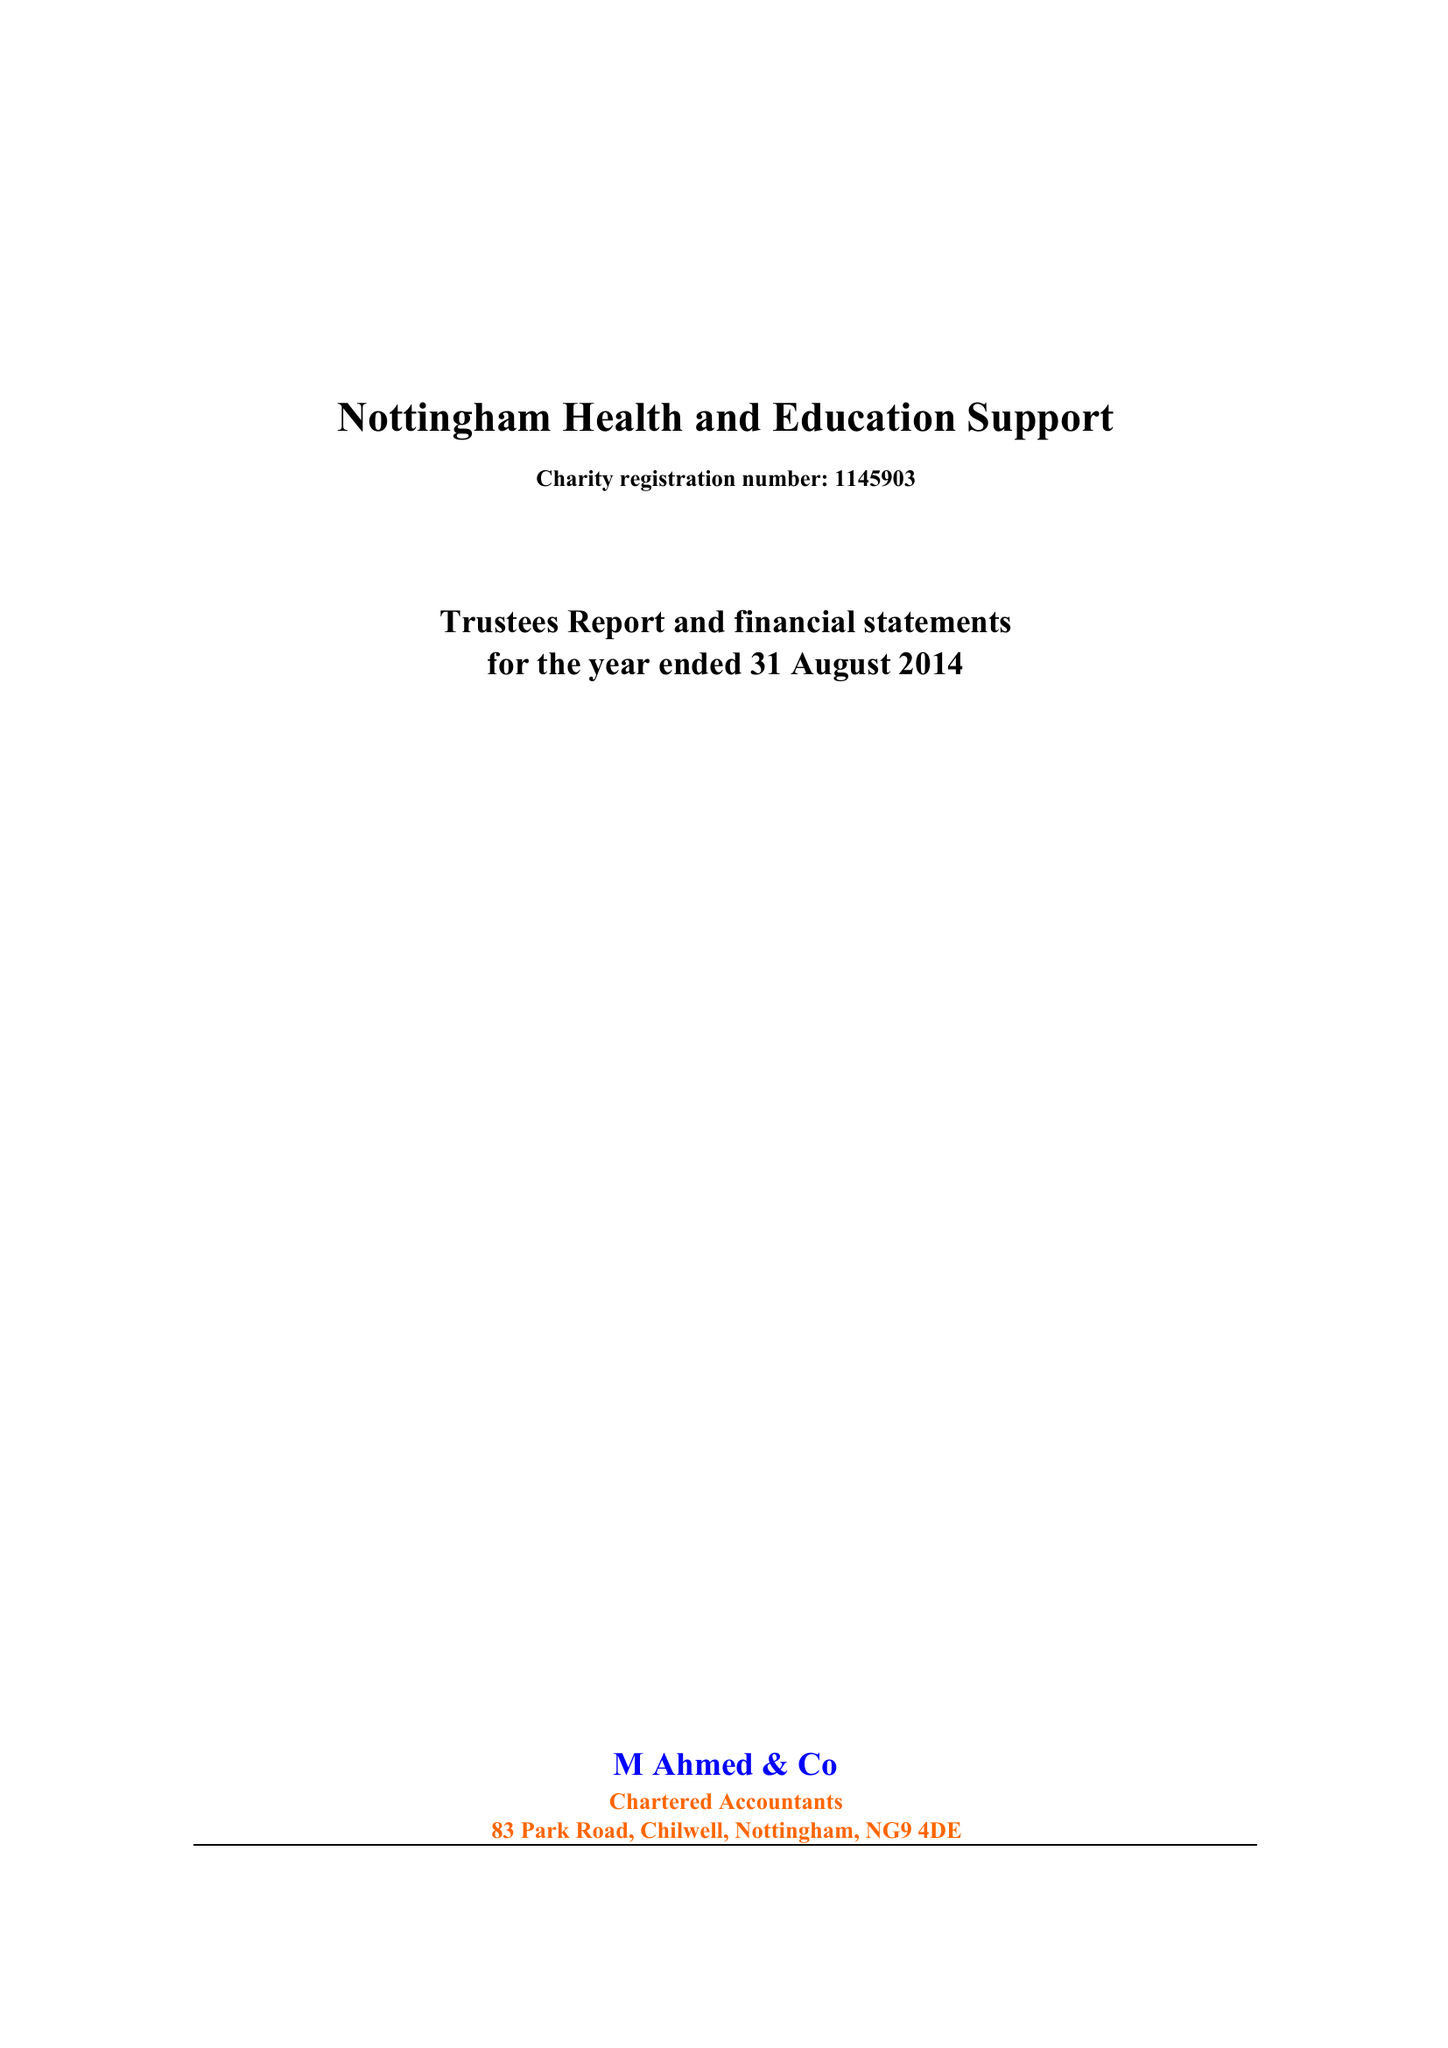What is the value for the charity_name?
Answer the question using a single word or phrase. Nottingham Health and Education Support 